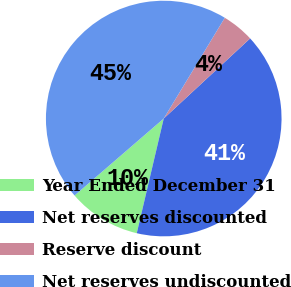Convert chart to OTSL. <chart><loc_0><loc_0><loc_500><loc_500><pie_chart><fcel>Year Ended December 31<fcel>Net reserves discounted<fcel>Reserve discount<fcel>Net reserves undiscounted<nl><fcel>9.99%<fcel>40.58%<fcel>4.43%<fcel>45.01%<nl></chart> 